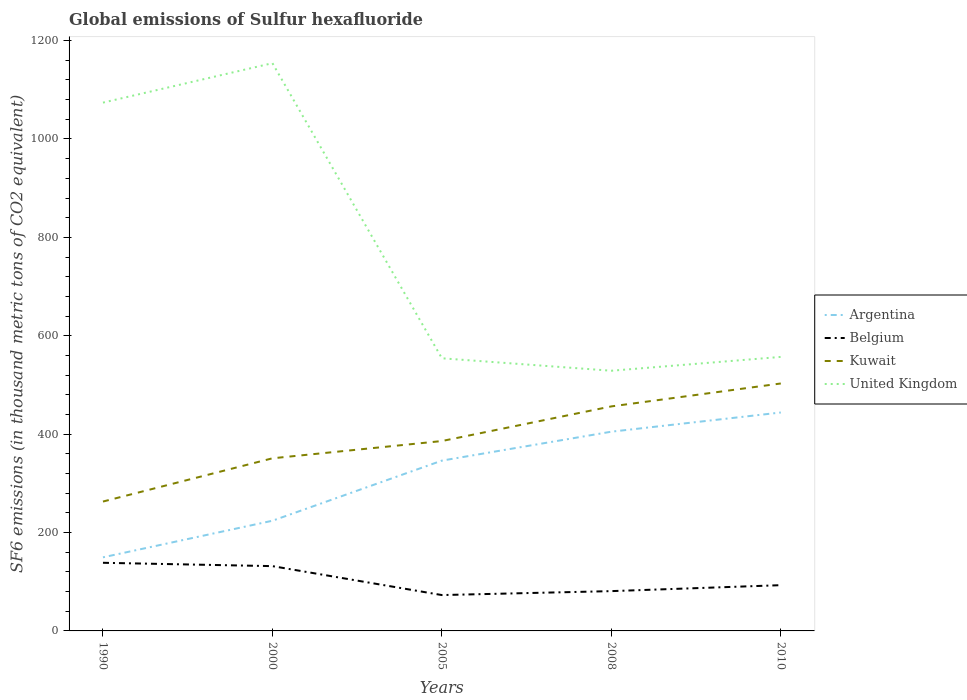How many different coloured lines are there?
Make the answer very short. 4. Does the line corresponding to Argentina intersect with the line corresponding to United Kingdom?
Ensure brevity in your answer.  No. Is the number of lines equal to the number of legend labels?
Make the answer very short. Yes. Across all years, what is the maximum global emissions of Sulfur hexafluoride in Argentina?
Your answer should be compact. 149.6. What is the total global emissions of Sulfur hexafluoride in Kuwait in the graph?
Offer a very short reply. -105.5. What is the difference between the highest and the second highest global emissions of Sulfur hexafluoride in Argentina?
Keep it short and to the point. 294.4. What is the difference between the highest and the lowest global emissions of Sulfur hexafluoride in Belgium?
Keep it short and to the point. 2. What is the difference between two consecutive major ticks on the Y-axis?
Ensure brevity in your answer.  200. Are the values on the major ticks of Y-axis written in scientific E-notation?
Offer a very short reply. No. Where does the legend appear in the graph?
Your answer should be very brief. Center right. How many legend labels are there?
Offer a terse response. 4. What is the title of the graph?
Your answer should be compact. Global emissions of Sulfur hexafluoride. Does "Andorra" appear as one of the legend labels in the graph?
Your answer should be very brief. No. What is the label or title of the X-axis?
Give a very brief answer. Years. What is the label or title of the Y-axis?
Ensure brevity in your answer.  SF6 emissions (in thousand metric tons of CO2 equivalent). What is the SF6 emissions (in thousand metric tons of CO2 equivalent) of Argentina in 1990?
Your answer should be compact. 149.6. What is the SF6 emissions (in thousand metric tons of CO2 equivalent) in Belgium in 1990?
Offer a terse response. 138.5. What is the SF6 emissions (in thousand metric tons of CO2 equivalent) in Kuwait in 1990?
Provide a succinct answer. 263. What is the SF6 emissions (in thousand metric tons of CO2 equivalent) in United Kingdom in 1990?
Ensure brevity in your answer.  1073.9. What is the SF6 emissions (in thousand metric tons of CO2 equivalent) in Argentina in 2000?
Your answer should be very brief. 224. What is the SF6 emissions (in thousand metric tons of CO2 equivalent) of Belgium in 2000?
Your answer should be compact. 131.7. What is the SF6 emissions (in thousand metric tons of CO2 equivalent) in Kuwait in 2000?
Give a very brief answer. 350.9. What is the SF6 emissions (in thousand metric tons of CO2 equivalent) in United Kingdom in 2000?
Ensure brevity in your answer.  1154.1. What is the SF6 emissions (in thousand metric tons of CO2 equivalent) of Argentina in 2005?
Offer a terse response. 346.2. What is the SF6 emissions (in thousand metric tons of CO2 equivalent) in Belgium in 2005?
Give a very brief answer. 72.9. What is the SF6 emissions (in thousand metric tons of CO2 equivalent) of Kuwait in 2005?
Provide a succinct answer. 386. What is the SF6 emissions (in thousand metric tons of CO2 equivalent) of United Kingdom in 2005?
Give a very brief answer. 554.2. What is the SF6 emissions (in thousand metric tons of CO2 equivalent) of Argentina in 2008?
Make the answer very short. 405. What is the SF6 emissions (in thousand metric tons of CO2 equivalent) of Belgium in 2008?
Your answer should be compact. 80.9. What is the SF6 emissions (in thousand metric tons of CO2 equivalent) in Kuwait in 2008?
Give a very brief answer. 456.4. What is the SF6 emissions (in thousand metric tons of CO2 equivalent) of United Kingdom in 2008?
Offer a very short reply. 528.9. What is the SF6 emissions (in thousand metric tons of CO2 equivalent) in Argentina in 2010?
Offer a very short reply. 444. What is the SF6 emissions (in thousand metric tons of CO2 equivalent) of Belgium in 2010?
Ensure brevity in your answer.  93. What is the SF6 emissions (in thousand metric tons of CO2 equivalent) of Kuwait in 2010?
Keep it short and to the point. 503. What is the SF6 emissions (in thousand metric tons of CO2 equivalent) of United Kingdom in 2010?
Your answer should be very brief. 557. Across all years, what is the maximum SF6 emissions (in thousand metric tons of CO2 equivalent) of Argentina?
Keep it short and to the point. 444. Across all years, what is the maximum SF6 emissions (in thousand metric tons of CO2 equivalent) of Belgium?
Keep it short and to the point. 138.5. Across all years, what is the maximum SF6 emissions (in thousand metric tons of CO2 equivalent) in Kuwait?
Keep it short and to the point. 503. Across all years, what is the maximum SF6 emissions (in thousand metric tons of CO2 equivalent) of United Kingdom?
Give a very brief answer. 1154.1. Across all years, what is the minimum SF6 emissions (in thousand metric tons of CO2 equivalent) of Argentina?
Offer a terse response. 149.6. Across all years, what is the minimum SF6 emissions (in thousand metric tons of CO2 equivalent) in Belgium?
Give a very brief answer. 72.9. Across all years, what is the minimum SF6 emissions (in thousand metric tons of CO2 equivalent) of Kuwait?
Provide a succinct answer. 263. Across all years, what is the minimum SF6 emissions (in thousand metric tons of CO2 equivalent) in United Kingdom?
Ensure brevity in your answer.  528.9. What is the total SF6 emissions (in thousand metric tons of CO2 equivalent) of Argentina in the graph?
Provide a succinct answer. 1568.8. What is the total SF6 emissions (in thousand metric tons of CO2 equivalent) in Belgium in the graph?
Your answer should be very brief. 517. What is the total SF6 emissions (in thousand metric tons of CO2 equivalent) of Kuwait in the graph?
Keep it short and to the point. 1959.3. What is the total SF6 emissions (in thousand metric tons of CO2 equivalent) of United Kingdom in the graph?
Your answer should be compact. 3868.1. What is the difference between the SF6 emissions (in thousand metric tons of CO2 equivalent) of Argentina in 1990 and that in 2000?
Offer a very short reply. -74.4. What is the difference between the SF6 emissions (in thousand metric tons of CO2 equivalent) of Belgium in 1990 and that in 2000?
Your response must be concise. 6.8. What is the difference between the SF6 emissions (in thousand metric tons of CO2 equivalent) of Kuwait in 1990 and that in 2000?
Give a very brief answer. -87.9. What is the difference between the SF6 emissions (in thousand metric tons of CO2 equivalent) in United Kingdom in 1990 and that in 2000?
Keep it short and to the point. -80.2. What is the difference between the SF6 emissions (in thousand metric tons of CO2 equivalent) in Argentina in 1990 and that in 2005?
Your answer should be very brief. -196.6. What is the difference between the SF6 emissions (in thousand metric tons of CO2 equivalent) in Belgium in 1990 and that in 2005?
Offer a terse response. 65.6. What is the difference between the SF6 emissions (in thousand metric tons of CO2 equivalent) of Kuwait in 1990 and that in 2005?
Provide a succinct answer. -123. What is the difference between the SF6 emissions (in thousand metric tons of CO2 equivalent) of United Kingdom in 1990 and that in 2005?
Provide a short and direct response. 519.7. What is the difference between the SF6 emissions (in thousand metric tons of CO2 equivalent) in Argentina in 1990 and that in 2008?
Make the answer very short. -255.4. What is the difference between the SF6 emissions (in thousand metric tons of CO2 equivalent) of Belgium in 1990 and that in 2008?
Your answer should be compact. 57.6. What is the difference between the SF6 emissions (in thousand metric tons of CO2 equivalent) of Kuwait in 1990 and that in 2008?
Make the answer very short. -193.4. What is the difference between the SF6 emissions (in thousand metric tons of CO2 equivalent) in United Kingdom in 1990 and that in 2008?
Ensure brevity in your answer.  545. What is the difference between the SF6 emissions (in thousand metric tons of CO2 equivalent) of Argentina in 1990 and that in 2010?
Keep it short and to the point. -294.4. What is the difference between the SF6 emissions (in thousand metric tons of CO2 equivalent) of Belgium in 1990 and that in 2010?
Offer a terse response. 45.5. What is the difference between the SF6 emissions (in thousand metric tons of CO2 equivalent) in Kuwait in 1990 and that in 2010?
Provide a succinct answer. -240. What is the difference between the SF6 emissions (in thousand metric tons of CO2 equivalent) of United Kingdom in 1990 and that in 2010?
Your response must be concise. 516.9. What is the difference between the SF6 emissions (in thousand metric tons of CO2 equivalent) in Argentina in 2000 and that in 2005?
Provide a short and direct response. -122.2. What is the difference between the SF6 emissions (in thousand metric tons of CO2 equivalent) of Belgium in 2000 and that in 2005?
Your answer should be compact. 58.8. What is the difference between the SF6 emissions (in thousand metric tons of CO2 equivalent) in Kuwait in 2000 and that in 2005?
Ensure brevity in your answer.  -35.1. What is the difference between the SF6 emissions (in thousand metric tons of CO2 equivalent) of United Kingdom in 2000 and that in 2005?
Keep it short and to the point. 599.9. What is the difference between the SF6 emissions (in thousand metric tons of CO2 equivalent) of Argentina in 2000 and that in 2008?
Give a very brief answer. -181. What is the difference between the SF6 emissions (in thousand metric tons of CO2 equivalent) of Belgium in 2000 and that in 2008?
Provide a short and direct response. 50.8. What is the difference between the SF6 emissions (in thousand metric tons of CO2 equivalent) of Kuwait in 2000 and that in 2008?
Keep it short and to the point. -105.5. What is the difference between the SF6 emissions (in thousand metric tons of CO2 equivalent) of United Kingdom in 2000 and that in 2008?
Your answer should be very brief. 625.2. What is the difference between the SF6 emissions (in thousand metric tons of CO2 equivalent) of Argentina in 2000 and that in 2010?
Provide a short and direct response. -220. What is the difference between the SF6 emissions (in thousand metric tons of CO2 equivalent) of Belgium in 2000 and that in 2010?
Offer a very short reply. 38.7. What is the difference between the SF6 emissions (in thousand metric tons of CO2 equivalent) of Kuwait in 2000 and that in 2010?
Your answer should be compact. -152.1. What is the difference between the SF6 emissions (in thousand metric tons of CO2 equivalent) of United Kingdom in 2000 and that in 2010?
Ensure brevity in your answer.  597.1. What is the difference between the SF6 emissions (in thousand metric tons of CO2 equivalent) of Argentina in 2005 and that in 2008?
Your answer should be compact. -58.8. What is the difference between the SF6 emissions (in thousand metric tons of CO2 equivalent) in Kuwait in 2005 and that in 2008?
Make the answer very short. -70.4. What is the difference between the SF6 emissions (in thousand metric tons of CO2 equivalent) of United Kingdom in 2005 and that in 2008?
Provide a succinct answer. 25.3. What is the difference between the SF6 emissions (in thousand metric tons of CO2 equivalent) of Argentina in 2005 and that in 2010?
Offer a terse response. -97.8. What is the difference between the SF6 emissions (in thousand metric tons of CO2 equivalent) in Belgium in 2005 and that in 2010?
Make the answer very short. -20.1. What is the difference between the SF6 emissions (in thousand metric tons of CO2 equivalent) of Kuwait in 2005 and that in 2010?
Provide a short and direct response. -117. What is the difference between the SF6 emissions (in thousand metric tons of CO2 equivalent) of Argentina in 2008 and that in 2010?
Give a very brief answer. -39. What is the difference between the SF6 emissions (in thousand metric tons of CO2 equivalent) in Belgium in 2008 and that in 2010?
Your answer should be very brief. -12.1. What is the difference between the SF6 emissions (in thousand metric tons of CO2 equivalent) of Kuwait in 2008 and that in 2010?
Offer a terse response. -46.6. What is the difference between the SF6 emissions (in thousand metric tons of CO2 equivalent) in United Kingdom in 2008 and that in 2010?
Make the answer very short. -28.1. What is the difference between the SF6 emissions (in thousand metric tons of CO2 equivalent) in Argentina in 1990 and the SF6 emissions (in thousand metric tons of CO2 equivalent) in Kuwait in 2000?
Keep it short and to the point. -201.3. What is the difference between the SF6 emissions (in thousand metric tons of CO2 equivalent) in Argentina in 1990 and the SF6 emissions (in thousand metric tons of CO2 equivalent) in United Kingdom in 2000?
Make the answer very short. -1004.5. What is the difference between the SF6 emissions (in thousand metric tons of CO2 equivalent) in Belgium in 1990 and the SF6 emissions (in thousand metric tons of CO2 equivalent) in Kuwait in 2000?
Provide a succinct answer. -212.4. What is the difference between the SF6 emissions (in thousand metric tons of CO2 equivalent) in Belgium in 1990 and the SF6 emissions (in thousand metric tons of CO2 equivalent) in United Kingdom in 2000?
Provide a succinct answer. -1015.6. What is the difference between the SF6 emissions (in thousand metric tons of CO2 equivalent) in Kuwait in 1990 and the SF6 emissions (in thousand metric tons of CO2 equivalent) in United Kingdom in 2000?
Your answer should be very brief. -891.1. What is the difference between the SF6 emissions (in thousand metric tons of CO2 equivalent) in Argentina in 1990 and the SF6 emissions (in thousand metric tons of CO2 equivalent) in Belgium in 2005?
Your response must be concise. 76.7. What is the difference between the SF6 emissions (in thousand metric tons of CO2 equivalent) of Argentina in 1990 and the SF6 emissions (in thousand metric tons of CO2 equivalent) of Kuwait in 2005?
Your response must be concise. -236.4. What is the difference between the SF6 emissions (in thousand metric tons of CO2 equivalent) of Argentina in 1990 and the SF6 emissions (in thousand metric tons of CO2 equivalent) of United Kingdom in 2005?
Offer a terse response. -404.6. What is the difference between the SF6 emissions (in thousand metric tons of CO2 equivalent) in Belgium in 1990 and the SF6 emissions (in thousand metric tons of CO2 equivalent) in Kuwait in 2005?
Provide a succinct answer. -247.5. What is the difference between the SF6 emissions (in thousand metric tons of CO2 equivalent) in Belgium in 1990 and the SF6 emissions (in thousand metric tons of CO2 equivalent) in United Kingdom in 2005?
Your response must be concise. -415.7. What is the difference between the SF6 emissions (in thousand metric tons of CO2 equivalent) in Kuwait in 1990 and the SF6 emissions (in thousand metric tons of CO2 equivalent) in United Kingdom in 2005?
Give a very brief answer. -291.2. What is the difference between the SF6 emissions (in thousand metric tons of CO2 equivalent) in Argentina in 1990 and the SF6 emissions (in thousand metric tons of CO2 equivalent) in Belgium in 2008?
Offer a very short reply. 68.7. What is the difference between the SF6 emissions (in thousand metric tons of CO2 equivalent) in Argentina in 1990 and the SF6 emissions (in thousand metric tons of CO2 equivalent) in Kuwait in 2008?
Your answer should be compact. -306.8. What is the difference between the SF6 emissions (in thousand metric tons of CO2 equivalent) in Argentina in 1990 and the SF6 emissions (in thousand metric tons of CO2 equivalent) in United Kingdom in 2008?
Provide a short and direct response. -379.3. What is the difference between the SF6 emissions (in thousand metric tons of CO2 equivalent) in Belgium in 1990 and the SF6 emissions (in thousand metric tons of CO2 equivalent) in Kuwait in 2008?
Provide a short and direct response. -317.9. What is the difference between the SF6 emissions (in thousand metric tons of CO2 equivalent) in Belgium in 1990 and the SF6 emissions (in thousand metric tons of CO2 equivalent) in United Kingdom in 2008?
Keep it short and to the point. -390.4. What is the difference between the SF6 emissions (in thousand metric tons of CO2 equivalent) in Kuwait in 1990 and the SF6 emissions (in thousand metric tons of CO2 equivalent) in United Kingdom in 2008?
Provide a short and direct response. -265.9. What is the difference between the SF6 emissions (in thousand metric tons of CO2 equivalent) of Argentina in 1990 and the SF6 emissions (in thousand metric tons of CO2 equivalent) of Belgium in 2010?
Keep it short and to the point. 56.6. What is the difference between the SF6 emissions (in thousand metric tons of CO2 equivalent) of Argentina in 1990 and the SF6 emissions (in thousand metric tons of CO2 equivalent) of Kuwait in 2010?
Your answer should be very brief. -353.4. What is the difference between the SF6 emissions (in thousand metric tons of CO2 equivalent) of Argentina in 1990 and the SF6 emissions (in thousand metric tons of CO2 equivalent) of United Kingdom in 2010?
Make the answer very short. -407.4. What is the difference between the SF6 emissions (in thousand metric tons of CO2 equivalent) of Belgium in 1990 and the SF6 emissions (in thousand metric tons of CO2 equivalent) of Kuwait in 2010?
Give a very brief answer. -364.5. What is the difference between the SF6 emissions (in thousand metric tons of CO2 equivalent) in Belgium in 1990 and the SF6 emissions (in thousand metric tons of CO2 equivalent) in United Kingdom in 2010?
Provide a short and direct response. -418.5. What is the difference between the SF6 emissions (in thousand metric tons of CO2 equivalent) in Kuwait in 1990 and the SF6 emissions (in thousand metric tons of CO2 equivalent) in United Kingdom in 2010?
Make the answer very short. -294. What is the difference between the SF6 emissions (in thousand metric tons of CO2 equivalent) of Argentina in 2000 and the SF6 emissions (in thousand metric tons of CO2 equivalent) of Belgium in 2005?
Offer a terse response. 151.1. What is the difference between the SF6 emissions (in thousand metric tons of CO2 equivalent) of Argentina in 2000 and the SF6 emissions (in thousand metric tons of CO2 equivalent) of Kuwait in 2005?
Offer a terse response. -162. What is the difference between the SF6 emissions (in thousand metric tons of CO2 equivalent) in Argentina in 2000 and the SF6 emissions (in thousand metric tons of CO2 equivalent) in United Kingdom in 2005?
Give a very brief answer. -330.2. What is the difference between the SF6 emissions (in thousand metric tons of CO2 equivalent) of Belgium in 2000 and the SF6 emissions (in thousand metric tons of CO2 equivalent) of Kuwait in 2005?
Ensure brevity in your answer.  -254.3. What is the difference between the SF6 emissions (in thousand metric tons of CO2 equivalent) of Belgium in 2000 and the SF6 emissions (in thousand metric tons of CO2 equivalent) of United Kingdom in 2005?
Ensure brevity in your answer.  -422.5. What is the difference between the SF6 emissions (in thousand metric tons of CO2 equivalent) in Kuwait in 2000 and the SF6 emissions (in thousand metric tons of CO2 equivalent) in United Kingdom in 2005?
Make the answer very short. -203.3. What is the difference between the SF6 emissions (in thousand metric tons of CO2 equivalent) of Argentina in 2000 and the SF6 emissions (in thousand metric tons of CO2 equivalent) of Belgium in 2008?
Provide a succinct answer. 143.1. What is the difference between the SF6 emissions (in thousand metric tons of CO2 equivalent) of Argentina in 2000 and the SF6 emissions (in thousand metric tons of CO2 equivalent) of Kuwait in 2008?
Make the answer very short. -232.4. What is the difference between the SF6 emissions (in thousand metric tons of CO2 equivalent) of Argentina in 2000 and the SF6 emissions (in thousand metric tons of CO2 equivalent) of United Kingdom in 2008?
Ensure brevity in your answer.  -304.9. What is the difference between the SF6 emissions (in thousand metric tons of CO2 equivalent) of Belgium in 2000 and the SF6 emissions (in thousand metric tons of CO2 equivalent) of Kuwait in 2008?
Your answer should be compact. -324.7. What is the difference between the SF6 emissions (in thousand metric tons of CO2 equivalent) of Belgium in 2000 and the SF6 emissions (in thousand metric tons of CO2 equivalent) of United Kingdom in 2008?
Your answer should be very brief. -397.2. What is the difference between the SF6 emissions (in thousand metric tons of CO2 equivalent) of Kuwait in 2000 and the SF6 emissions (in thousand metric tons of CO2 equivalent) of United Kingdom in 2008?
Offer a very short reply. -178. What is the difference between the SF6 emissions (in thousand metric tons of CO2 equivalent) in Argentina in 2000 and the SF6 emissions (in thousand metric tons of CO2 equivalent) in Belgium in 2010?
Give a very brief answer. 131. What is the difference between the SF6 emissions (in thousand metric tons of CO2 equivalent) of Argentina in 2000 and the SF6 emissions (in thousand metric tons of CO2 equivalent) of Kuwait in 2010?
Keep it short and to the point. -279. What is the difference between the SF6 emissions (in thousand metric tons of CO2 equivalent) of Argentina in 2000 and the SF6 emissions (in thousand metric tons of CO2 equivalent) of United Kingdom in 2010?
Give a very brief answer. -333. What is the difference between the SF6 emissions (in thousand metric tons of CO2 equivalent) in Belgium in 2000 and the SF6 emissions (in thousand metric tons of CO2 equivalent) in Kuwait in 2010?
Keep it short and to the point. -371.3. What is the difference between the SF6 emissions (in thousand metric tons of CO2 equivalent) of Belgium in 2000 and the SF6 emissions (in thousand metric tons of CO2 equivalent) of United Kingdom in 2010?
Your response must be concise. -425.3. What is the difference between the SF6 emissions (in thousand metric tons of CO2 equivalent) in Kuwait in 2000 and the SF6 emissions (in thousand metric tons of CO2 equivalent) in United Kingdom in 2010?
Your answer should be compact. -206.1. What is the difference between the SF6 emissions (in thousand metric tons of CO2 equivalent) in Argentina in 2005 and the SF6 emissions (in thousand metric tons of CO2 equivalent) in Belgium in 2008?
Your answer should be compact. 265.3. What is the difference between the SF6 emissions (in thousand metric tons of CO2 equivalent) in Argentina in 2005 and the SF6 emissions (in thousand metric tons of CO2 equivalent) in Kuwait in 2008?
Provide a succinct answer. -110.2. What is the difference between the SF6 emissions (in thousand metric tons of CO2 equivalent) of Argentina in 2005 and the SF6 emissions (in thousand metric tons of CO2 equivalent) of United Kingdom in 2008?
Offer a very short reply. -182.7. What is the difference between the SF6 emissions (in thousand metric tons of CO2 equivalent) of Belgium in 2005 and the SF6 emissions (in thousand metric tons of CO2 equivalent) of Kuwait in 2008?
Your response must be concise. -383.5. What is the difference between the SF6 emissions (in thousand metric tons of CO2 equivalent) of Belgium in 2005 and the SF6 emissions (in thousand metric tons of CO2 equivalent) of United Kingdom in 2008?
Your answer should be compact. -456. What is the difference between the SF6 emissions (in thousand metric tons of CO2 equivalent) in Kuwait in 2005 and the SF6 emissions (in thousand metric tons of CO2 equivalent) in United Kingdom in 2008?
Your response must be concise. -142.9. What is the difference between the SF6 emissions (in thousand metric tons of CO2 equivalent) of Argentina in 2005 and the SF6 emissions (in thousand metric tons of CO2 equivalent) of Belgium in 2010?
Your answer should be very brief. 253.2. What is the difference between the SF6 emissions (in thousand metric tons of CO2 equivalent) in Argentina in 2005 and the SF6 emissions (in thousand metric tons of CO2 equivalent) in Kuwait in 2010?
Offer a very short reply. -156.8. What is the difference between the SF6 emissions (in thousand metric tons of CO2 equivalent) in Argentina in 2005 and the SF6 emissions (in thousand metric tons of CO2 equivalent) in United Kingdom in 2010?
Offer a terse response. -210.8. What is the difference between the SF6 emissions (in thousand metric tons of CO2 equivalent) of Belgium in 2005 and the SF6 emissions (in thousand metric tons of CO2 equivalent) of Kuwait in 2010?
Offer a terse response. -430.1. What is the difference between the SF6 emissions (in thousand metric tons of CO2 equivalent) in Belgium in 2005 and the SF6 emissions (in thousand metric tons of CO2 equivalent) in United Kingdom in 2010?
Offer a very short reply. -484.1. What is the difference between the SF6 emissions (in thousand metric tons of CO2 equivalent) in Kuwait in 2005 and the SF6 emissions (in thousand metric tons of CO2 equivalent) in United Kingdom in 2010?
Make the answer very short. -171. What is the difference between the SF6 emissions (in thousand metric tons of CO2 equivalent) of Argentina in 2008 and the SF6 emissions (in thousand metric tons of CO2 equivalent) of Belgium in 2010?
Make the answer very short. 312. What is the difference between the SF6 emissions (in thousand metric tons of CO2 equivalent) of Argentina in 2008 and the SF6 emissions (in thousand metric tons of CO2 equivalent) of Kuwait in 2010?
Offer a very short reply. -98. What is the difference between the SF6 emissions (in thousand metric tons of CO2 equivalent) of Argentina in 2008 and the SF6 emissions (in thousand metric tons of CO2 equivalent) of United Kingdom in 2010?
Offer a very short reply. -152. What is the difference between the SF6 emissions (in thousand metric tons of CO2 equivalent) in Belgium in 2008 and the SF6 emissions (in thousand metric tons of CO2 equivalent) in Kuwait in 2010?
Provide a succinct answer. -422.1. What is the difference between the SF6 emissions (in thousand metric tons of CO2 equivalent) of Belgium in 2008 and the SF6 emissions (in thousand metric tons of CO2 equivalent) of United Kingdom in 2010?
Provide a short and direct response. -476.1. What is the difference between the SF6 emissions (in thousand metric tons of CO2 equivalent) of Kuwait in 2008 and the SF6 emissions (in thousand metric tons of CO2 equivalent) of United Kingdom in 2010?
Keep it short and to the point. -100.6. What is the average SF6 emissions (in thousand metric tons of CO2 equivalent) in Argentina per year?
Your response must be concise. 313.76. What is the average SF6 emissions (in thousand metric tons of CO2 equivalent) of Belgium per year?
Offer a terse response. 103.4. What is the average SF6 emissions (in thousand metric tons of CO2 equivalent) of Kuwait per year?
Offer a very short reply. 391.86. What is the average SF6 emissions (in thousand metric tons of CO2 equivalent) in United Kingdom per year?
Make the answer very short. 773.62. In the year 1990, what is the difference between the SF6 emissions (in thousand metric tons of CO2 equivalent) in Argentina and SF6 emissions (in thousand metric tons of CO2 equivalent) in Kuwait?
Your answer should be very brief. -113.4. In the year 1990, what is the difference between the SF6 emissions (in thousand metric tons of CO2 equivalent) of Argentina and SF6 emissions (in thousand metric tons of CO2 equivalent) of United Kingdom?
Offer a very short reply. -924.3. In the year 1990, what is the difference between the SF6 emissions (in thousand metric tons of CO2 equivalent) of Belgium and SF6 emissions (in thousand metric tons of CO2 equivalent) of Kuwait?
Your answer should be very brief. -124.5. In the year 1990, what is the difference between the SF6 emissions (in thousand metric tons of CO2 equivalent) in Belgium and SF6 emissions (in thousand metric tons of CO2 equivalent) in United Kingdom?
Make the answer very short. -935.4. In the year 1990, what is the difference between the SF6 emissions (in thousand metric tons of CO2 equivalent) of Kuwait and SF6 emissions (in thousand metric tons of CO2 equivalent) of United Kingdom?
Your response must be concise. -810.9. In the year 2000, what is the difference between the SF6 emissions (in thousand metric tons of CO2 equivalent) in Argentina and SF6 emissions (in thousand metric tons of CO2 equivalent) in Belgium?
Provide a short and direct response. 92.3. In the year 2000, what is the difference between the SF6 emissions (in thousand metric tons of CO2 equivalent) in Argentina and SF6 emissions (in thousand metric tons of CO2 equivalent) in Kuwait?
Your response must be concise. -126.9. In the year 2000, what is the difference between the SF6 emissions (in thousand metric tons of CO2 equivalent) in Argentina and SF6 emissions (in thousand metric tons of CO2 equivalent) in United Kingdom?
Provide a succinct answer. -930.1. In the year 2000, what is the difference between the SF6 emissions (in thousand metric tons of CO2 equivalent) of Belgium and SF6 emissions (in thousand metric tons of CO2 equivalent) of Kuwait?
Provide a succinct answer. -219.2. In the year 2000, what is the difference between the SF6 emissions (in thousand metric tons of CO2 equivalent) of Belgium and SF6 emissions (in thousand metric tons of CO2 equivalent) of United Kingdom?
Give a very brief answer. -1022.4. In the year 2000, what is the difference between the SF6 emissions (in thousand metric tons of CO2 equivalent) in Kuwait and SF6 emissions (in thousand metric tons of CO2 equivalent) in United Kingdom?
Keep it short and to the point. -803.2. In the year 2005, what is the difference between the SF6 emissions (in thousand metric tons of CO2 equivalent) of Argentina and SF6 emissions (in thousand metric tons of CO2 equivalent) of Belgium?
Make the answer very short. 273.3. In the year 2005, what is the difference between the SF6 emissions (in thousand metric tons of CO2 equivalent) of Argentina and SF6 emissions (in thousand metric tons of CO2 equivalent) of Kuwait?
Your response must be concise. -39.8. In the year 2005, what is the difference between the SF6 emissions (in thousand metric tons of CO2 equivalent) of Argentina and SF6 emissions (in thousand metric tons of CO2 equivalent) of United Kingdom?
Provide a succinct answer. -208. In the year 2005, what is the difference between the SF6 emissions (in thousand metric tons of CO2 equivalent) in Belgium and SF6 emissions (in thousand metric tons of CO2 equivalent) in Kuwait?
Offer a very short reply. -313.1. In the year 2005, what is the difference between the SF6 emissions (in thousand metric tons of CO2 equivalent) in Belgium and SF6 emissions (in thousand metric tons of CO2 equivalent) in United Kingdom?
Give a very brief answer. -481.3. In the year 2005, what is the difference between the SF6 emissions (in thousand metric tons of CO2 equivalent) in Kuwait and SF6 emissions (in thousand metric tons of CO2 equivalent) in United Kingdom?
Keep it short and to the point. -168.2. In the year 2008, what is the difference between the SF6 emissions (in thousand metric tons of CO2 equivalent) of Argentina and SF6 emissions (in thousand metric tons of CO2 equivalent) of Belgium?
Keep it short and to the point. 324.1. In the year 2008, what is the difference between the SF6 emissions (in thousand metric tons of CO2 equivalent) in Argentina and SF6 emissions (in thousand metric tons of CO2 equivalent) in Kuwait?
Provide a short and direct response. -51.4. In the year 2008, what is the difference between the SF6 emissions (in thousand metric tons of CO2 equivalent) in Argentina and SF6 emissions (in thousand metric tons of CO2 equivalent) in United Kingdom?
Provide a short and direct response. -123.9. In the year 2008, what is the difference between the SF6 emissions (in thousand metric tons of CO2 equivalent) in Belgium and SF6 emissions (in thousand metric tons of CO2 equivalent) in Kuwait?
Offer a terse response. -375.5. In the year 2008, what is the difference between the SF6 emissions (in thousand metric tons of CO2 equivalent) of Belgium and SF6 emissions (in thousand metric tons of CO2 equivalent) of United Kingdom?
Provide a short and direct response. -448. In the year 2008, what is the difference between the SF6 emissions (in thousand metric tons of CO2 equivalent) in Kuwait and SF6 emissions (in thousand metric tons of CO2 equivalent) in United Kingdom?
Make the answer very short. -72.5. In the year 2010, what is the difference between the SF6 emissions (in thousand metric tons of CO2 equivalent) in Argentina and SF6 emissions (in thousand metric tons of CO2 equivalent) in Belgium?
Keep it short and to the point. 351. In the year 2010, what is the difference between the SF6 emissions (in thousand metric tons of CO2 equivalent) of Argentina and SF6 emissions (in thousand metric tons of CO2 equivalent) of Kuwait?
Offer a terse response. -59. In the year 2010, what is the difference between the SF6 emissions (in thousand metric tons of CO2 equivalent) of Argentina and SF6 emissions (in thousand metric tons of CO2 equivalent) of United Kingdom?
Make the answer very short. -113. In the year 2010, what is the difference between the SF6 emissions (in thousand metric tons of CO2 equivalent) in Belgium and SF6 emissions (in thousand metric tons of CO2 equivalent) in Kuwait?
Offer a very short reply. -410. In the year 2010, what is the difference between the SF6 emissions (in thousand metric tons of CO2 equivalent) of Belgium and SF6 emissions (in thousand metric tons of CO2 equivalent) of United Kingdom?
Ensure brevity in your answer.  -464. In the year 2010, what is the difference between the SF6 emissions (in thousand metric tons of CO2 equivalent) of Kuwait and SF6 emissions (in thousand metric tons of CO2 equivalent) of United Kingdom?
Offer a terse response. -54. What is the ratio of the SF6 emissions (in thousand metric tons of CO2 equivalent) of Argentina in 1990 to that in 2000?
Provide a short and direct response. 0.67. What is the ratio of the SF6 emissions (in thousand metric tons of CO2 equivalent) in Belgium in 1990 to that in 2000?
Provide a succinct answer. 1.05. What is the ratio of the SF6 emissions (in thousand metric tons of CO2 equivalent) of Kuwait in 1990 to that in 2000?
Your answer should be very brief. 0.75. What is the ratio of the SF6 emissions (in thousand metric tons of CO2 equivalent) in United Kingdom in 1990 to that in 2000?
Offer a terse response. 0.93. What is the ratio of the SF6 emissions (in thousand metric tons of CO2 equivalent) of Argentina in 1990 to that in 2005?
Ensure brevity in your answer.  0.43. What is the ratio of the SF6 emissions (in thousand metric tons of CO2 equivalent) of Belgium in 1990 to that in 2005?
Give a very brief answer. 1.9. What is the ratio of the SF6 emissions (in thousand metric tons of CO2 equivalent) in Kuwait in 1990 to that in 2005?
Your answer should be compact. 0.68. What is the ratio of the SF6 emissions (in thousand metric tons of CO2 equivalent) in United Kingdom in 1990 to that in 2005?
Keep it short and to the point. 1.94. What is the ratio of the SF6 emissions (in thousand metric tons of CO2 equivalent) of Argentina in 1990 to that in 2008?
Your answer should be compact. 0.37. What is the ratio of the SF6 emissions (in thousand metric tons of CO2 equivalent) of Belgium in 1990 to that in 2008?
Your answer should be compact. 1.71. What is the ratio of the SF6 emissions (in thousand metric tons of CO2 equivalent) in Kuwait in 1990 to that in 2008?
Your response must be concise. 0.58. What is the ratio of the SF6 emissions (in thousand metric tons of CO2 equivalent) of United Kingdom in 1990 to that in 2008?
Provide a succinct answer. 2.03. What is the ratio of the SF6 emissions (in thousand metric tons of CO2 equivalent) of Argentina in 1990 to that in 2010?
Give a very brief answer. 0.34. What is the ratio of the SF6 emissions (in thousand metric tons of CO2 equivalent) of Belgium in 1990 to that in 2010?
Your answer should be very brief. 1.49. What is the ratio of the SF6 emissions (in thousand metric tons of CO2 equivalent) in Kuwait in 1990 to that in 2010?
Keep it short and to the point. 0.52. What is the ratio of the SF6 emissions (in thousand metric tons of CO2 equivalent) of United Kingdom in 1990 to that in 2010?
Provide a short and direct response. 1.93. What is the ratio of the SF6 emissions (in thousand metric tons of CO2 equivalent) of Argentina in 2000 to that in 2005?
Your answer should be very brief. 0.65. What is the ratio of the SF6 emissions (in thousand metric tons of CO2 equivalent) of Belgium in 2000 to that in 2005?
Offer a terse response. 1.81. What is the ratio of the SF6 emissions (in thousand metric tons of CO2 equivalent) of United Kingdom in 2000 to that in 2005?
Provide a short and direct response. 2.08. What is the ratio of the SF6 emissions (in thousand metric tons of CO2 equivalent) in Argentina in 2000 to that in 2008?
Your answer should be very brief. 0.55. What is the ratio of the SF6 emissions (in thousand metric tons of CO2 equivalent) in Belgium in 2000 to that in 2008?
Make the answer very short. 1.63. What is the ratio of the SF6 emissions (in thousand metric tons of CO2 equivalent) of Kuwait in 2000 to that in 2008?
Give a very brief answer. 0.77. What is the ratio of the SF6 emissions (in thousand metric tons of CO2 equivalent) of United Kingdom in 2000 to that in 2008?
Provide a short and direct response. 2.18. What is the ratio of the SF6 emissions (in thousand metric tons of CO2 equivalent) in Argentina in 2000 to that in 2010?
Provide a short and direct response. 0.5. What is the ratio of the SF6 emissions (in thousand metric tons of CO2 equivalent) in Belgium in 2000 to that in 2010?
Your answer should be very brief. 1.42. What is the ratio of the SF6 emissions (in thousand metric tons of CO2 equivalent) of Kuwait in 2000 to that in 2010?
Your answer should be compact. 0.7. What is the ratio of the SF6 emissions (in thousand metric tons of CO2 equivalent) of United Kingdom in 2000 to that in 2010?
Keep it short and to the point. 2.07. What is the ratio of the SF6 emissions (in thousand metric tons of CO2 equivalent) in Argentina in 2005 to that in 2008?
Make the answer very short. 0.85. What is the ratio of the SF6 emissions (in thousand metric tons of CO2 equivalent) in Belgium in 2005 to that in 2008?
Provide a succinct answer. 0.9. What is the ratio of the SF6 emissions (in thousand metric tons of CO2 equivalent) in Kuwait in 2005 to that in 2008?
Your answer should be very brief. 0.85. What is the ratio of the SF6 emissions (in thousand metric tons of CO2 equivalent) in United Kingdom in 2005 to that in 2008?
Make the answer very short. 1.05. What is the ratio of the SF6 emissions (in thousand metric tons of CO2 equivalent) of Argentina in 2005 to that in 2010?
Offer a terse response. 0.78. What is the ratio of the SF6 emissions (in thousand metric tons of CO2 equivalent) of Belgium in 2005 to that in 2010?
Make the answer very short. 0.78. What is the ratio of the SF6 emissions (in thousand metric tons of CO2 equivalent) in Kuwait in 2005 to that in 2010?
Provide a succinct answer. 0.77. What is the ratio of the SF6 emissions (in thousand metric tons of CO2 equivalent) of United Kingdom in 2005 to that in 2010?
Your answer should be compact. 0.99. What is the ratio of the SF6 emissions (in thousand metric tons of CO2 equivalent) of Argentina in 2008 to that in 2010?
Your answer should be very brief. 0.91. What is the ratio of the SF6 emissions (in thousand metric tons of CO2 equivalent) in Belgium in 2008 to that in 2010?
Offer a terse response. 0.87. What is the ratio of the SF6 emissions (in thousand metric tons of CO2 equivalent) of Kuwait in 2008 to that in 2010?
Give a very brief answer. 0.91. What is the ratio of the SF6 emissions (in thousand metric tons of CO2 equivalent) of United Kingdom in 2008 to that in 2010?
Give a very brief answer. 0.95. What is the difference between the highest and the second highest SF6 emissions (in thousand metric tons of CO2 equivalent) in Argentina?
Ensure brevity in your answer.  39. What is the difference between the highest and the second highest SF6 emissions (in thousand metric tons of CO2 equivalent) of Belgium?
Provide a succinct answer. 6.8. What is the difference between the highest and the second highest SF6 emissions (in thousand metric tons of CO2 equivalent) in Kuwait?
Give a very brief answer. 46.6. What is the difference between the highest and the second highest SF6 emissions (in thousand metric tons of CO2 equivalent) in United Kingdom?
Provide a succinct answer. 80.2. What is the difference between the highest and the lowest SF6 emissions (in thousand metric tons of CO2 equivalent) of Argentina?
Provide a succinct answer. 294.4. What is the difference between the highest and the lowest SF6 emissions (in thousand metric tons of CO2 equivalent) of Belgium?
Your answer should be compact. 65.6. What is the difference between the highest and the lowest SF6 emissions (in thousand metric tons of CO2 equivalent) of Kuwait?
Your answer should be very brief. 240. What is the difference between the highest and the lowest SF6 emissions (in thousand metric tons of CO2 equivalent) in United Kingdom?
Offer a terse response. 625.2. 